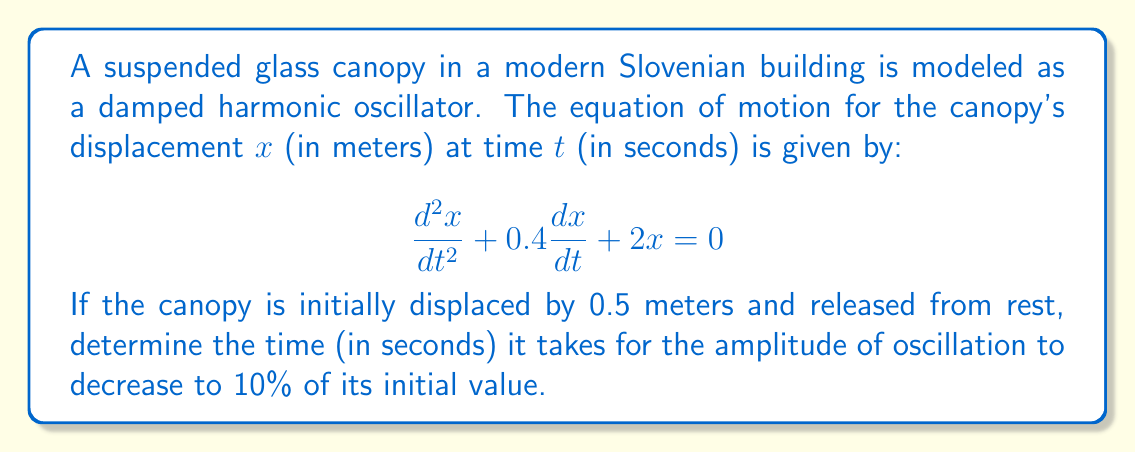Give your solution to this math problem. To solve this problem, we'll follow these steps:

1) The general solution for a damped harmonic oscillator is:
   $$x(t) = Ae^{-\gamma t}\cos(\omega t + \phi)$$
   where $A$ is the initial amplitude, $\gamma$ is the damping coefficient, and $\omega$ is the angular frequency.

2) From the given equation, we can identify:
   $\gamma = 0.2$ (half of the coefficient of $\frac{dx}{dt}$)
   $\omega_0^2 = 2$ (coefficient of $x$)

3) The amplitude of oscillation decreases according to $e^{-\gamma t}$. We need to find $t$ when:
   $$e^{-\gamma t} = 0.1$$

4) Taking the natural logarithm of both sides:
   $$-\gamma t = \ln(0.1)$$
   $$t = -\frac{\ln(0.1)}{\gamma}$$

5) Substituting $\gamma = 0.2$:
   $$t = -\frac{\ln(0.1)}{0.2}$$

6) Calculating the result:
   $$t = -\frac{-2.30259}{0.2} \approx 11.51295$$

Therefore, it takes approximately 11.51 seconds for the amplitude to decrease to 10% of its initial value.
Answer: 11.51 seconds 